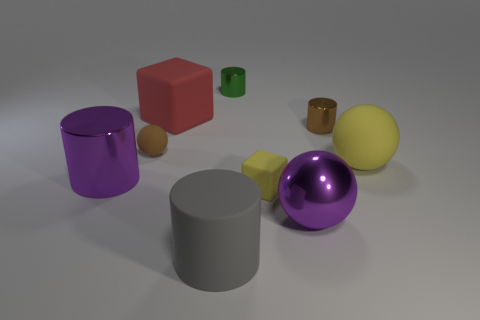What number of tiny metal things are the same color as the small ball?
Keep it short and to the point. 1. How many other things are there of the same color as the small rubber sphere?
Your answer should be compact. 1. There is a tiny object that is the same color as the small rubber sphere; what is its material?
Make the answer very short. Metal. There is a brown thing that is on the right side of the large shiny ball; is its size the same as the purple cylinder that is in front of the tiny green cylinder?
Give a very brief answer. No. Is there a tiny yellow cylinder that has the same material as the brown cylinder?
Ensure brevity in your answer.  No. There is a matte thing that is the same color as the tiny matte cube; what is its size?
Provide a short and direct response. Large. Are there any small brown metallic cylinders left of the block behind the small metallic cylinder that is right of the small yellow cube?
Provide a succinct answer. No. There is a large block; are there any big red rubber things behind it?
Your answer should be compact. No. There is a purple thing on the left side of the big gray cylinder; how many gray things are behind it?
Your answer should be very brief. 0. There is a red matte thing; does it have the same size as the matte ball to the right of the gray rubber cylinder?
Give a very brief answer. Yes. 